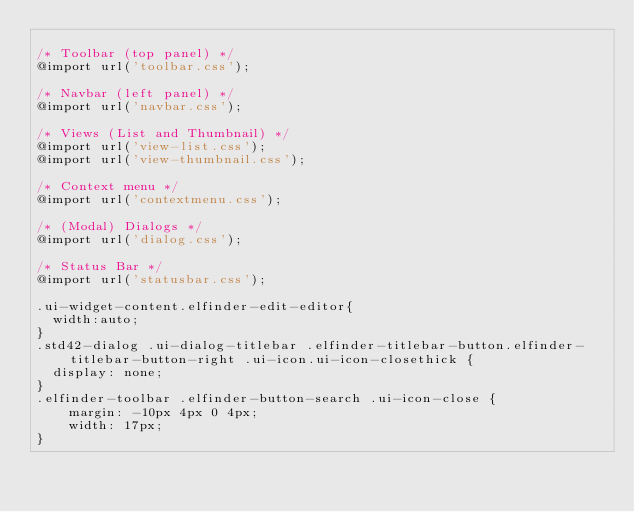<code> <loc_0><loc_0><loc_500><loc_500><_CSS_>
/* Toolbar (top panel) */
@import url('toolbar.css');

/* Navbar (left panel) */
@import url('navbar.css');

/* Views (List and Thumbnail) */
@import url('view-list.css');
@import url('view-thumbnail.css');

/* Context menu */
@import url('contextmenu.css');

/* (Modal) Dialogs */
@import url('dialog.css');

/* Status Bar */
@import url('statusbar.css');

.ui-widget-content.elfinder-edit-editor{
	width:auto;
}
.std42-dialog .ui-dialog-titlebar .elfinder-titlebar-button.elfinder-titlebar-button-right .ui-icon.ui-icon-closethick {
	display: none;
}
.elfinder-toolbar .elfinder-button-search .ui-icon-close {
    margin: -10px 4px 0 4px;
    width: 17px;
}</code> 